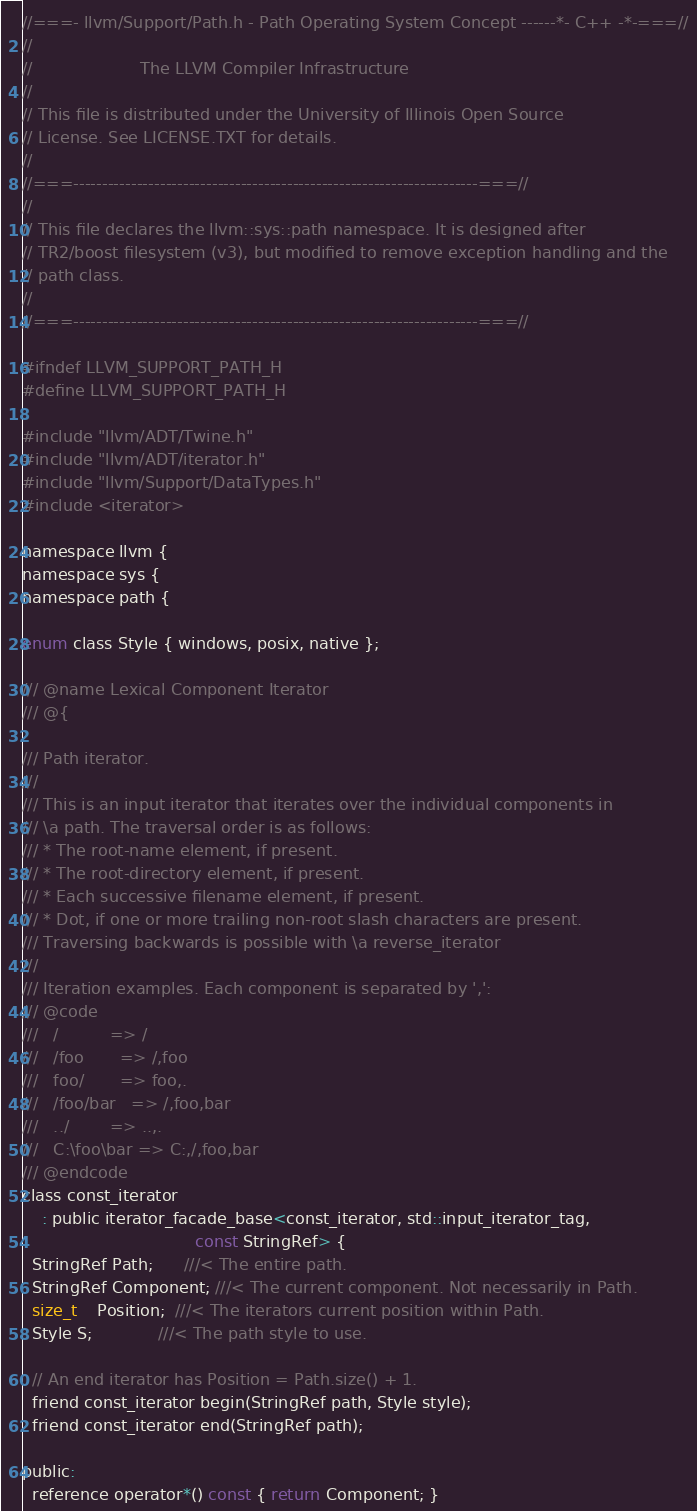Convert code to text. <code><loc_0><loc_0><loc_500><loc_500><_C_>//===- llvm/Support/Path.h - Path Operating System Concept ------*- C++ -*-===//
//
//                     The LLVM Compiler Infrastructure
//
// This file is distributed under the University of Illinois Open Source
// License. See LICENSE.TXT for details.
//
//===----------------------------------------------------------------------===//
//
// This file declares the llvm::sys::path namespace. It is designed after
// TR2/boost filesystem (v3), but modified to remove exception handling and the
// path class.
//
//===----------------------------------------------------------------------===//

#ifndef LLVM_SUPPORT_PATH_H
#define LLVM_SUPPORT_PATH_H

#include "llvm/ADT/Twine.h"
#include "llvm/ADT/iterator.h"
#include "llvm/Support/DataTypes.h"
#include <iterator>

namespace llvm {
namespace sys {
namespace path {

enum class Style { windows, posix, native };

/// @name Lexical Component Iterator
/// @{

/// Path iterator.
///
/// This is an input iterator that iterates over the individual components in
/// \a path. The traversal order is as follows:
/// * The root-name element, if present.
/// * The root-directory element, if present.
/// * Each successive filename element, if present.
/// * Dot, if one or more trailing non-root slash characters are present.
/// Traversing backwards is possible with \a reverse_iterator
///
/// Iteration examples. Each component is separated by ',':
/// @code
///   /          => /
///   /foo       => /,foo
///   foo/       => foo,.
///   /foo/bar   => /,foo,bar
///   ../        => ..,.
///   C:\foo\bar => C:,/,foo,bar
/// @endcode
class const_iterator
    : public iterator_facade_base<const_iterator, std::input_iterator_tag,
                                  const StringRef> {
  StringRef Path;      ///< The entire path.
  StringRef Component; ///< The current component. Not necessarily in Path.
  size_t    Position;  ///< The iterators current position within Path.
  Style S;             ///< The path style to use.

  // An end iterator has Position = Path.size() + 1.
  friend const_iterator begin(StringRef path, Style style);
  friend const_iterator end(StringRef path);

public:
  reference operator*() const { return Component; }</code> 